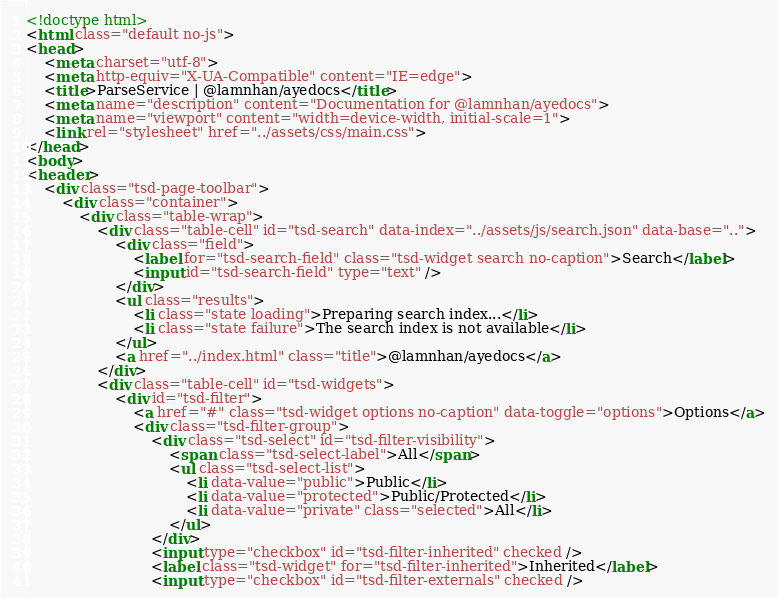<code> <loc_0><loc_0><loc_500><loc_500><_HTML_><!doctype html>
<html class="default no-js">
<head>
	<meta charset="utf-8">
	<meta http-equiv="X-UA-Compatible" content="IE=edge">
	<title>ParseService | @lamnhan/ayedocs</title>
	<meta name="description" content="Documentation for @lamnhan/ayedocs">
	<meta name="viewport" content="width=device-width, initial-scale=1">
	<link rel="stylesheet" href="../assets/css/main.css">
</head>
<body>
<header>
	<div class="tsd-page-toolbar">
		<div class="container">
			<div class="table-wrap">
				<div class="table-cell" id="tsd-search" data-index="../assets/js/search.json" data-base="..">
					<div class="field">
						<label for="tsd-search-field" class="tsd-widget search no-caption">Search</label>
						<input id="tsd-search-field" type="text" />
					</div>
					<ul class="results">
						<li class="state loading">Preparing search index...</li>
						<li class="state failure">The search index is not available</li>
					</ul>
					<a href="../index.html" class="title">@lamnhan/ayedocs</a>
				</div>
				<div class="table-cell" id="tsd-widgets">
					<div id="tsd-filter">
						<a href="#" class="tsd-widget options no-caption" data-toggle="options">Options</a>
						<div class="tsd-filter-group">
							<div class="tsd-select" id="tsd-filter-visibility">
								<span class="tsd-select-label">All</span>
								<ul class="tsd-select-list">
									<li data-value="public">Public</li>
									<li data-value="protected">Public/Protected</li>
									<li data-value="private" class="selected">All</li>
								</ul>
							</div>
							<input type="checkbox" id="tsd-filter-inherited" checked />
							<label class="tsd-widget" for="tsd-filter-inherited">Inherited</label>
							<input type="checkbox" id="tsd-filter-externals" checked /></code> 